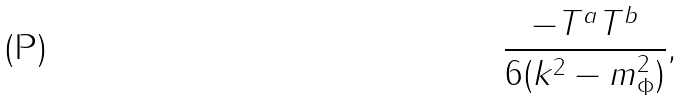Convert formula to latex. <formula><loc_0><loc_0><loc_500><loc_500>\frac { - T ^ { a } T ^ { b } } { 6 ( k ^ { 2 } - m _ { \Phi } ^ { 2 } ) } ,</formula> 